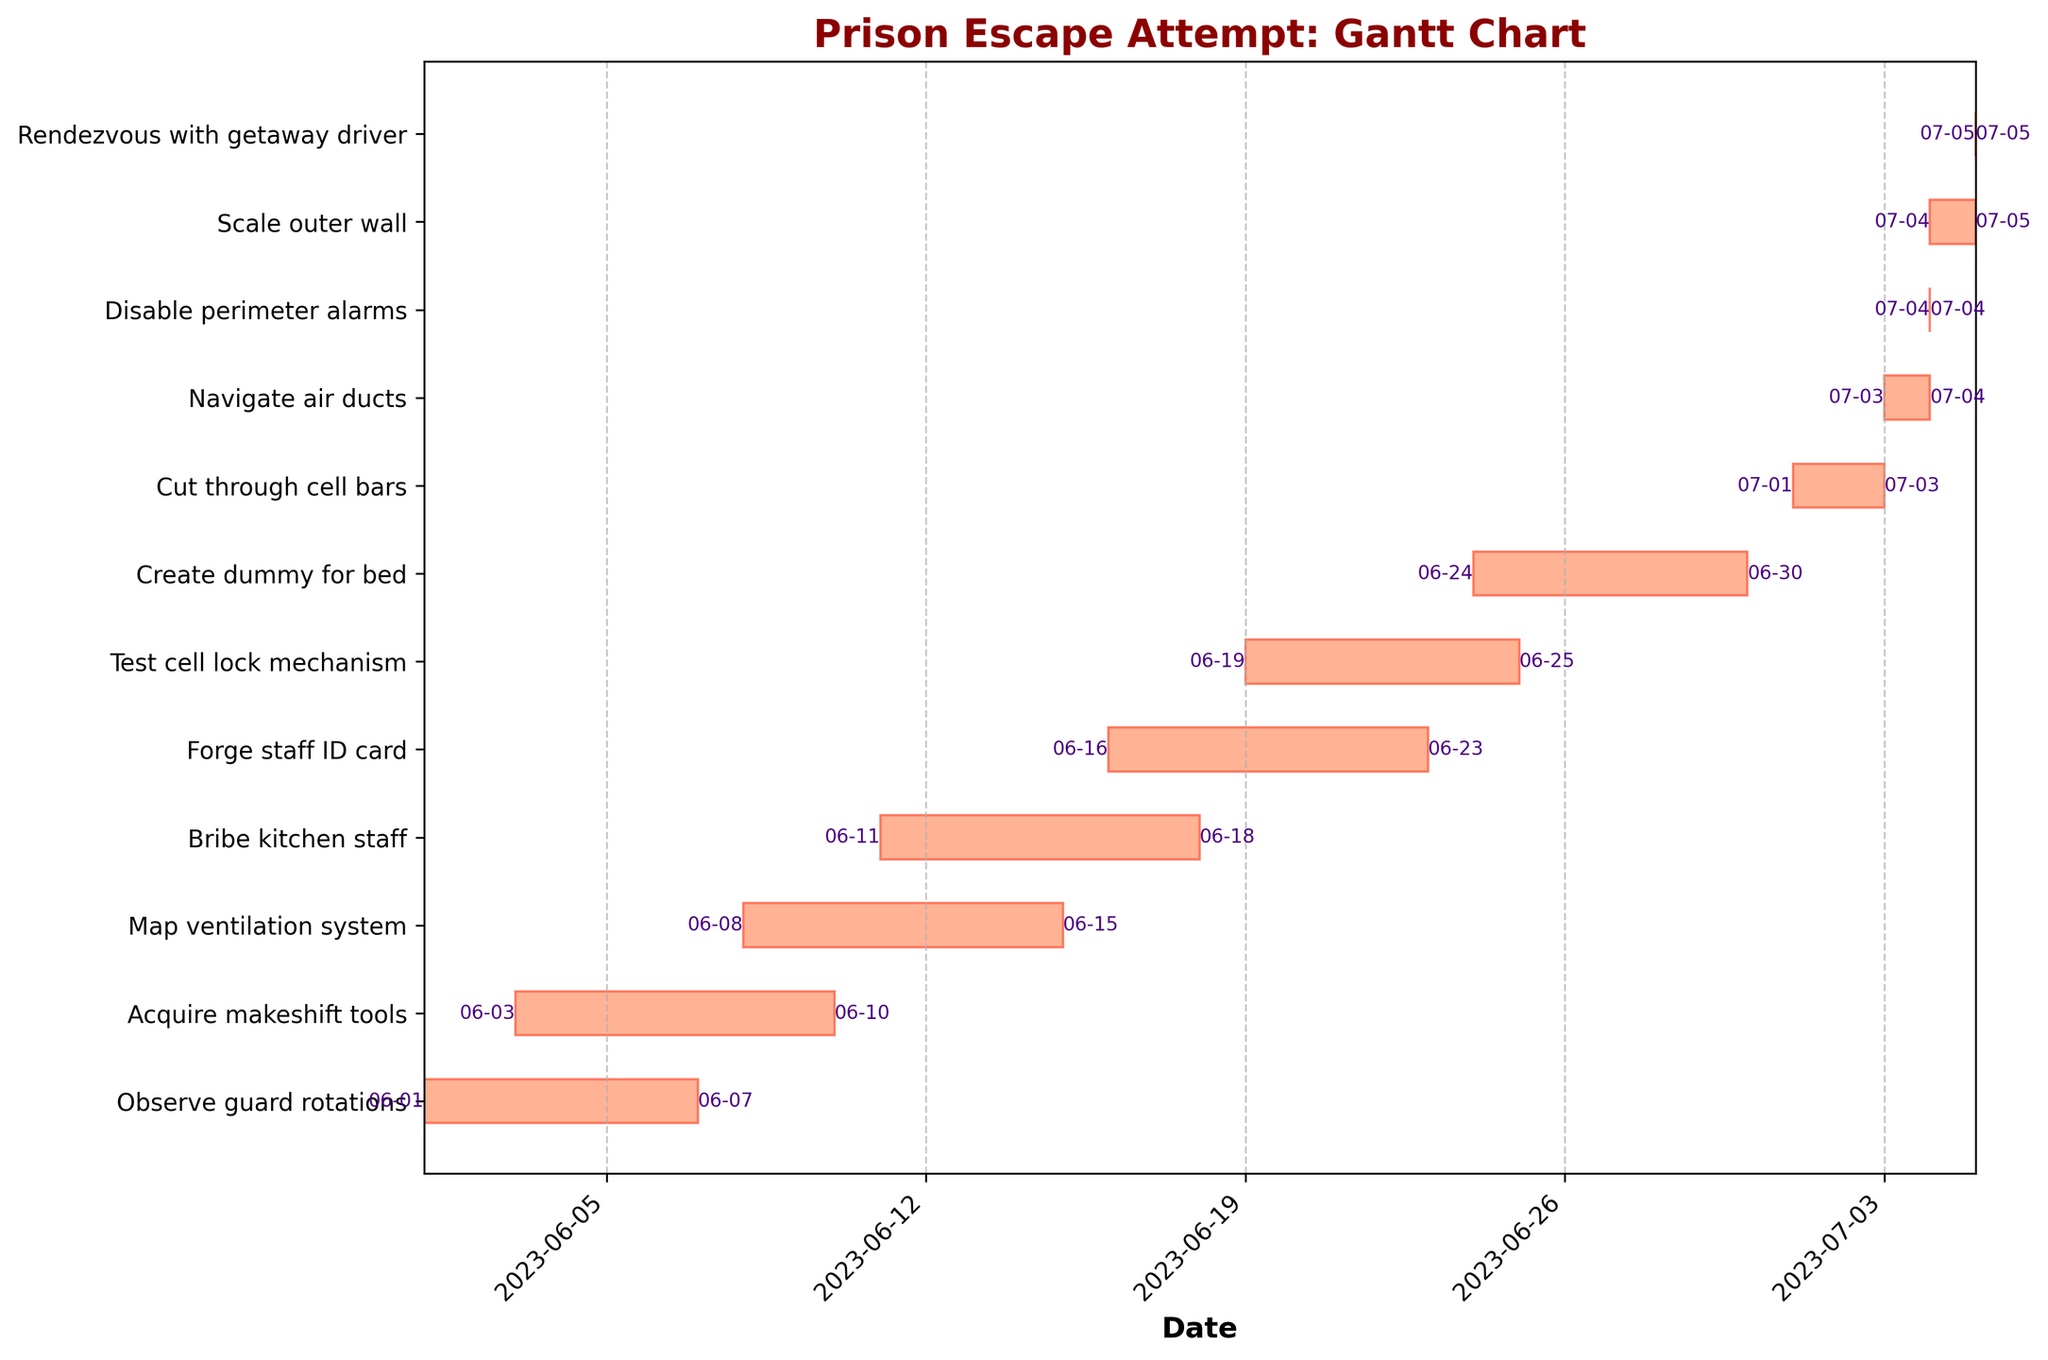What is the title of the chart? The title is typically located at the top of the chart. In this case, it reads "Prison Escape Attempt: Gantt Chart."
Answer: Prison Escape Attempt: Gantt Chart How many tasks are detailed in the chart? To find the number of tasks, count the number of bars or the number of y-axis labels.
Answer: 12 Which task has the longest duration? Observe each task's duration by looking at the width of the bars. The task with the widest bar has the longest duration. "Acquire makeshift tools" spans from June 3 to June 10, totaling 7 days.
Answer: Acquire makeshift tools Which tasks start and end on the same day? Tasks that start and end on the same day will have very short or almost invisible bars. From visual inspection, "Disable perimeter alarms," "Scale outer wall," and "Rendezvous with getaway driver" fit this criterion.
Answer: Disable perimeter alarms, Rendezvous with getaway driver How many tasks are completed by June 20th? Look at the end dates for each task. Count how many tasks have an end date on or before June 20th. "Observe guard rotations," "Acquire makeshift tools," "Map ventilation system," and "Bribe kitchen staff" end on or before June 20th.
Answer: 4 Which task ends last and on what date? The last task ends on the latest date. "Rendezvous with getaway driver" ends on July 5th.
Answer: Rendezvous with getaway driver, July 5 What is the total duration of the preparation phase? Sum the durations of tasks that are part of the preparation phase. These tasks are usually the initial ones up to "Create dummy for bed." Add the lengths from "Observe guard rotations" to "Create dummy for bed."
Answer: 30 days How does the duration of "Cut through cell bars" compare to "Scale outer wall"? Check the widths of the corresponding bars. "Cut through cell bars" spans 3 days (July 1 to July 3), while "Scale outer wall" spans 1 day (July 4 to July 5). "Cut through cell bars" takes longer.
Answer: Cut through cell bars is longer Do any two tasks have the exact same start date? Which ones? Examine the start dates listed by each bar. "Cut through cell bars" and "Navigate air ducts" both start on July 3rd.
Answer: Cut through cell bars and Navigate air ducts What task is performed right after "Test cell lock mechanism"? Find "Test cell lock mechanism" on the y-axis and look at the task directly below it. "Create dummy for bed" is performed next.
Answer: Create dummy for bed 